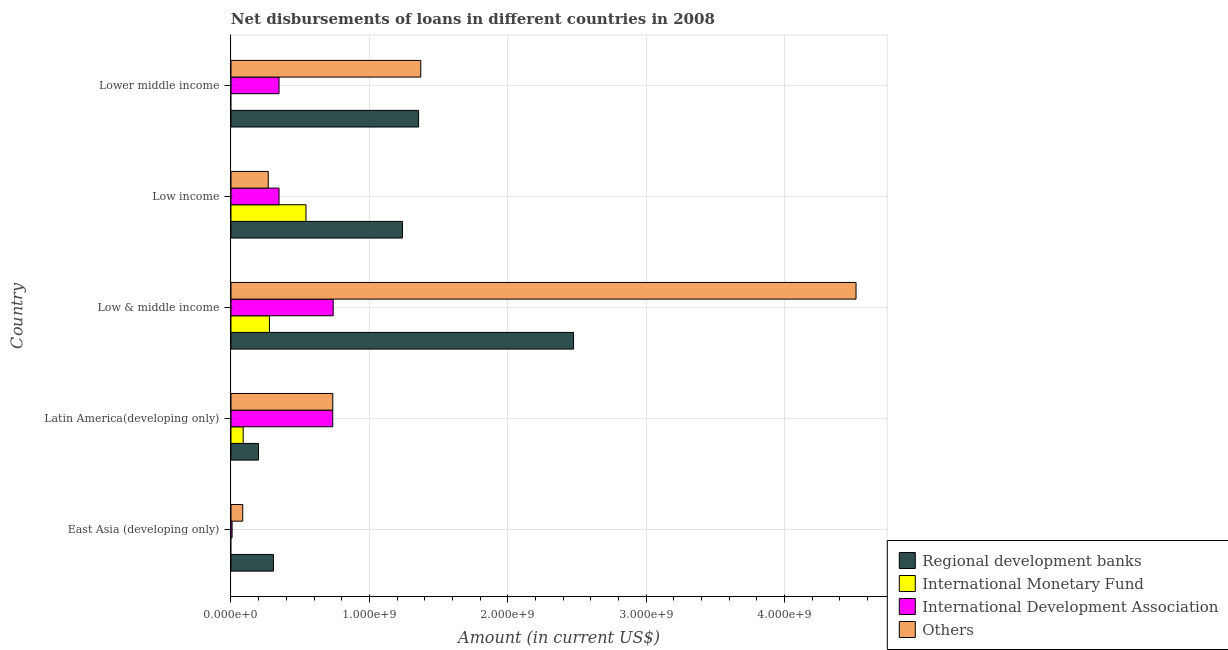Are the number of bars on each tick of the Y-axis equal?
Your answer should be compact. No. What is the label of the 1st group of bars from the top?
Keep it short and to the point. Lower middle income. In how many cases, is the number of bars for a given country not equal to the number of legend labels?
Ensure brevity in your answer.  2. What is the amount of loan disimbursed by regional development banks in East Asia (developing only)?
Give a very brief answer. 3.07e+08. Across all countries, what is the maximum amount of loan disimbursed by international monetary fund?
Your response must be concise. 5.42e+08. Across all countries, what is the minimum amount of loan disimbursed by other organisations?
Ensure brevity in your answer.  8.50e+07. In which country was the amount of loan disimbursed by regional development banks maximum?
Make the answer very short. Low & middle income. What is the total amount of loan disimbursed by regional development banks in the graph?
Your answer should be compact. 5.58e+09. What is the difference between the amount of loan disimbursed by international development association in Latin America(developing only) and that in Low & middle income?
Give a very brief answer. -3.47e+06. What is the difference between the amount of loan disimbursed by international monetary fund in Low & middle income and the amount of loan disimbursed by other organisations in East Asia (developing only)?
Make the answer very short. 1.93e+08. What is the average amount of loan disimbursed by international monetary fund per country?
Your answer should be very brief. 1.82e+08. What is the difference between the amount of loan disimbursed by international development association and amount of loan disimbursed by other organisations in East Asia (developing only)?
Give a very brief answer. -7.71e+07. What is the ratio of the amount of loan disimbursed by regional development banks in Low & middle income to that in Low income?
Your answer should be compact. 2. Is the amount of loan disimbursed by international monetary fund in Latin America(developing only) less than that in Low income?
Offer a terse response. Yes. Is the difference between the amount of loan disimbursed by regional development banks in East Asia (developing only) and Low income greater than the difference between the amount of loan disimbursed by other organisations in East Asia (developing only) and Low income?
Your answer should be very brief. No. What is the difference between the highest and the second highest amount of loan disimbursed by regional development banks?
Keep it short and to the point. 1.12e+09. What is the difference between the highest and the lowest amount of loan disimbursed by international monetary fund?
Your response must be concise. 5.42e+08. In how many countries, is the amount of loan disimbursed by regional development banks greater than the average amount of loan disimbursed by regional development banks taken over all countries?
Ensure brevity in your answer.  3. Is it the case that in every country, the sum of the amount of loan disimbursed by regional development banks and amount of loan disimbursed by international development association is greater than the sum of amount of loan disimbursed by other organisations and amount of loan disimbursed by international monetary fund?
Your response must be concise. No. Is it the case that in every country, the sum of the amount of loan disimbursed by regional development banks and amount of loan disimbursed by international monetary fund is greater than the amount of loan disimbursed by international development association?
Your answer should be very brief. No. How many bars are there?
Keep it short and to the point. 18. Are all the bars in the graph horizontal?
Make the answer very short. Yes. How many countries are there in the graph?
Make the answer very short. 5. What is the difference between two consecutive major ticks on the X-axis?
Offer a terse response. 1.00e+09. Does the graph contain grids?
Your answer should be very brief. Yes. How many legend labels are there?
Your answer should be very brief. 4. How are the legend labels stacked?
Make the answer very short. Vertical. What is the title of the graph?
Offer a terse response. Net disbursements of loans in different countries in 2008. Does "Italy" appear as one of the legend labels in the graph?
Your answer should be compact. No. What is the label or title of the X-axis?
Offer a very short reply. Amount (in current US$). What is the Amount (in current US$) in Regional development banks in East Asia (developing only)?
Your response must be concise. 3.07e+08. What is the Amount (in current US$) of International Monetary Fund in East Asia (developing only)?
Your answer should be very brief. 0. What is the Amount (in current US$) in International Development Association in East Asia (developing only)?
Offer a terse response. 7.98e+06. What is the Amount (in current US$) of Others in East Asia (developing only)?
Offer a terse response. 8.50e+07. What is the Amount (in current US$) of Regional development banks in Latin America(developing only)?
Keep it short and to the point. 1.99e+08. What is the Amount (in current US$) of International Monetary Fund in Latin America(developing only)?
Keep it short and to the point. 8.81e+07. What is the Amount (in current US$) in International Development Association in Latin America(developing only)?
Ensure brevity in your answer.  7.35e+08. What is the Amount (in current US$) in Others in Latin America(developing only)?
Keep it short and to the point. 7.36e+08. What is the Amount (in current US$) of Regional development banks in Low & middle income?
Make the answer very short. 2.48e+09. What is the Amount (in current US$) in International Monetary Fund in Low & middle income?
Provide a short and direct response. 2.78e+08. What is the Amount (in current US$) in International Development Association in Low & middle income?
Provide a short and direct response. 7.39e+08. What is the Amount (in current US$) in Others in Low & middle income?
Offer a terse response. 4.52e+09. What is the Amount (in current US$) of Regional development banks in Low income?
Offer a terse response. 1.24e+09. What is the Amount (in current US$) of International Monetary Fund in Low income?
Your answer should be very brief. 5.42e+08. What is the Amount (in current US$) of International Development Association in Low income?
Provide a short and direct response. 3.47e+08. What is the Amount (in current US$) in Others in Low income?
Your answer should be very brief. 2.69e+08. What is the Amount (in current US$) of Regional development banks in Lower middle income?
Provide a short and direct response. 1.36e+09. What is the Amount (in current US$) in International Development Association in Lower middle income?
Your answer should be compact. 3.47e+08. What is the Amount (in current US$) of Others in Lower middle income?
Provide a succinct answer. 1.37e+09. Across all countries, what is the maximum Amount (in current US$) in Regional development banks?
Provide a succinct answer. 2.48e+09. Across all countries, what is the maximum Amount (in current US$) of International Monetary Fund?
Offer a terse response. 5.42e+08. Across all countries, what is the maximum Amount (in current US$) in International Development Association?
Offer a very short reply. 7.39e+08. Across all countries, what is the maximum Amount (in current US$) in Others?
Your answer should be compact. 4.52e+09. Across all countries, what is the minimum Amount (in current US$) in Regional development banks?
Ensure brevity in your answer.  1.99e+08. Across all countries, what is the minimum Amount (in current US$) of International Development Association?
Provide a succinct answer. 7.98e+06. Across all countries, what is the minimum Amount (in current US$) of Others?
Make the answer very short. 8.50e+07. What is the total Amount (in current US$) of Regional development banks in the graph?
Your answer should be very brief. 5.58e+09. What is the total Amount (in current US$) of International Monetary Fund in the graph?
Offer a terse response. 9.08e+08. What is the total Amount (in current US$) in International Development Association in the graph?
Give a very brief answer. 2.18e+09. What is the total Amount (in current US$) of Others in the graph?
Your response must be concise. 6.98e+09. What is the difference between the Amount (in current US$) in Regional development banks in East Asia (developing only) and that in Latin America(developing only)?
Keep it short and to the point. 1.08e+08. What is the difference between the Amount (in current US$) of International Development Association in East Asia (developing only) and that in Latin America(developing only)?
Keep it short and to the point. -7.27e+08. What is the difference between the Amount (in current US$) of Others in East Asia (developing only) and that in Latin America(developing only)?
Offer a terse response. -6.51e+08. What is the difference between the Amount (in current US$) in Regional development banks in East Asia (developing only) and that in Low & middle income?
Offer a very short reply. -2.17e+09. What is the difference between the Amount (in current US$) in International Development Association in East Asia (developing only) and that in Low & middle income?
Give a very brief answer. -7.31e+08. What is the difference between the Amount (in current US$) in Others in East Asia (developing only) and that in Low & middle income?
Your answer should be compact. -4.43e+09. What is the difference between the Amount (in current US$) in Regional development banks in East Asia (developing only) and that in Low income?
Offer a very short reply. -9.32e+08. What is the difference between the Amount (in current US$) of International Development Association in East Asia (developing only) and that in Low income?
Make the answer very short. -3.39e+08. What is the difference between the Amount (in current US$) of Others in East Asia (developing only) and that in Low income?
Ensure brevity in your answer.  -1.84e+08. What is the difference between the Amount (in current US$) in Regional development banks in East Asia (developing only) and that in Lower middle income?
Make the answer very short. -1.05e+09. What is the difference between the Amount (in current US$) of International Development Association in East Asia (developing only) and that in Lower middle income?
Offer a very short reply. -3.39e+08. What is the difference between the Amount (in current US$) in Others in East Asia (developing only) and that in Lower middle income?
Your answer should be compact. -1.29e+09. What is the difference between the Amount (in current US$) in Regional development banks in Latin America(developing only) and that in Low & middle income?
Offer a very short reply. -2.28e+09. What is the difference between the Amount (in current US$) in International Monetary Fund in Latin America(developing only) and that in Low & middle income?
Your answer should be very brief. -1.90e+08. What is the difference between the Amount (in current US$) of International Development Association in Latin America(developing only) and that in Low & middle income?
Your answer should be compact. -3.47e+06. What is the difference between the Amount (in current US$) in Others in Latin America(developing only) and that in Low & middle income?
Your answer should be compact. -3.78e+09. What is the difference between the Amount (in current US$) of Regional development banks in Latin America(developing only) and that in Low income?
Provide a short and direct response. -1.04e+09. What is the difference between the Amount (in current US$) in International Monetary Fund in Latin America(developing only) and that in Low income?
Provide a short and direct response. -4.54e+08. What is the difference between the Amount (in current US$) in International Development Association in Latin America(developing only) and that in Low income?
Offer a very short reply. 3.88e+08. What is the difference between the Amount (in current US$) of Others in Latin America(developing only) and that in Low income?
Keep it short and to the point. 4.66e+08. What is the difference between the Amount (in current US$) of Regional development banks in Latin America(developing only) and that in Lower middle income?
Make the answer very short. -1.16e+09. What is the difference between the Amount (in current US$) in International Development Association in Latin America(developing only) and that in Lower middle income?
Make the answer very short. 3.88e+08. What is the difference between the Amount (in current US$) of Others in Latin America(developing only) and that in Lower middle income?
Offer a terse response. -6.36e+08. What is the difference between the Amount (in current US$) of Regional development banks in Low & middle income and that in Low income?
Make the answer very short. 1.24e+09. What is the difference between the Amount (in current US$) in International Monetary Fund in Low & middle income and that in Low income?
Keep it short and to the point. -2.64e+08. What is the difference between the Amount (in current US$) of International Development Association in Low & middle income and that in Low income?
Give a very brief answer. 3.91e+08. What is the difference between the Amount (in current US$) of Others in Low & middle income and that in Low income?
Give a very brief answer. 4.25e+09. What is the difference between the Amount (in current US$) in Regional development banks in Low & middle income and that in Lower middle income?
Provide a short and direct response. 1.12e+09. What is the difference between the Amount (in current US$) in International Development Association in Low & middle income and that in Lower middle income?
Offer a terse response. 3.91e+08. What is the difference between the Amount (in current US$) in Others in Low & middle income and that in Lower middle income?
Your response must be concise. 3.14e+09. What is the difference between the Amount (in current US$) in Regional development banks in Low income and that in Lower middle income?
Your response must be concise. -1.16e+08. What is the difference between the Amount (in current US$) of Others in Low income and that in Lower middle income?
Provide a succinct answer. -1.10e+09. What is the difference between the Amount (in current US$) in Regional development banks in East Asia (developing only) and the Amount (in current US$) in International Monetary Fund in Latin America(developing only)?
Your answer should be very brief. 2.19e+08. What is the difference between the Amount (in current US$) in Regional development banks in East Asia (developing only) and the Amount (in current US$) in International Development Association in Latin America(developing only)?
Your response must be concise. -4.28e+08. What is the difference between the Amount (in current US$) in Regional development banks in East Asia (developing only) and the Amount (in current US$) in Others in Latin America(developing only)?
Provide a short and direct response. -4.29e+08. What is the difference between the Amount (in current US$) in International Development Association in East Asia (developing only) and the Amount (in current US$) in Others in Latin America(developing only)?
Give a very brief answer. -7.28e+08. What is the difference between the Amount (in current US$) of Regional development banks in East Asia (developing only) and the Amount (in current US$) of International Monetary Fund in Low & middle income?
Offer a very short reply. 2.89e+07. What is the difference between the Amount (in current US$) of Regional development banks in East Asia (developing only) and the Amount (in current US$) of International Development Association in Low & middle income?
Your answer should be very brief. -4.32e+08. What is the difference between the Amount (in current US$) in Regional development banks in East Asia (developing only) and the Amount (in current US$) in Others in Low & middle income?
Ensure brevity in your answer.  -4.21e+09. What is the difference between the Amount (in current US$) in International Development Association in East Asia (developing only) and the Amount (in current US$) in Others in Low & middle income?
Give a very brief answer. -4.51e+09. What is the difference between the Amount (in current US$) of Regional development banks in East Asia (developing only) and the Amount (in current US$) of International Monetary Fund in Low income?
Make the answer very short. -2.35e+08. What is the difference between the Amount (in current US$) of Regional development banks in East Asia (developing only) and the Amount (in current US$) of International Development Association in Low income?
Keep it short and to the point. -4.06e+07. What is the difference between the Amount (in current US$) in Regional development banks in East Asia (developing only) and the Amount (in current US$) in Others in Low income?
Your answer should be compact. 3.74e+07. What is the difference between the Amount (in current US$) of International Development Association in East Asia (developing only) and the Amount (in current US$) of Others in Low income?
Make the answer very short. -2.61e+08. What is the difference between the Amount (in current US$) in Regional development banks in East Asia (developing only) and the Amount (in current US$) in International Development Association in Lower middle income?
Offer a terse response. -4.06e+07. What is the difference between the Amount (in current US$) of Regional development banks in East Asia (developing only) and the Amount (in current US$) of Others in Lower middle income?
Offer a very short reply. -1.06e+09. What is the difference between the Amount (in current US$) of International Development Association in East Asia (developing only) and the Amount (in current US$) of Others in Lower middle income?
Your response must be concise. -1.36e+09. What is the difference between the Amount (in current US$) in Regional development banks in Latin America(developing only) and the Amount (in current US$) in International Monetary Fund in Low & middle income?
Offer a terse response. -7.86e+07. What is the difference between the Amount (in current US$) of Regional development banks in Latin America(developing only) and the Amount (in current US$) of International Development Association in Low & middle income?
Make the answer very short. -5.39e+08. What is the difference between the Amount (in current US$) of Regional development banks in Latin America(developing only) and the Amount (in current US$) of Others in Low & middle income?
Offer a terse response. -4.32e+09. What is the difference between the Amount (in current US$) in International Monetary Fund in Latin America(developing only) and the Amount (in current US$) in International Development Association in Low & middle income?
Offer a very short reply. -6.50e+08. What is the difference between the Amount (in current US$) in International Monetary Fund in Latin America(developing only) and the Amount (in current US$) in Others in Low & middle income?
Your answer should be compact. -4.43e+09. What is the difference between the Amount (in current US$) of International Development Association in Latin America(developing only) and the Amount (in current US$) of Others in Low & middle income?
Offer a very short reply. -3.78e+09. What is the difference between the Amount (in current US$) of Regional development banks in Latin America(developing only) and the Amount (in current US$) of International Monetary Fund in Low income?
Give a very brief answer. -3.43e+08. What is the difference between the Amount (in current US$) of Regional development banks in Latin America(developing only) and the Amount (in current US$) of International Development Association in Low income?
Your answer should be compact. -1.48e+08. What is the difference between the Amount (in current US$) of Regional development banks in Latin America(developing only) and the Amount (in current US$) of Others in Low income?
Keep it short and to the point. -7.01e+07. What is the difference between the Amount (in current US$) in International Monetary Fund in Latin America(developing only) and the Amount (in current US$) in International Development Association in Low income?
Provide a succinct answer. -2.59e+08. What is the difference between the Amount (in current US$) in International Monetary Fund in Latin America(developing only) and the Amount (in current US$) in Others in Low income?
Give a very brief answer. -1.81e+08. What is the difference between the Amount (in current US$) of International Development Association in Latin America(developing only) and the Amount (in current US$) of Others in Low income?
Keep it short and to the point. 4.66e+08. What is the difference between the Amount (in current US$) in Regional development banks in Latin America(developing only) and the Amount (in current US$) in International Development Association in Lower middle income?
Keep it short and to the point. -1.48e+08. What is the difference between the Amount (in current US$) in Regional development banks in Latin America(developing only) and the Amount (in current US$) in Others in Lower middle income?
Offer a very short reply. -1.17e+09. What is the difference between the Amount (in current US$) of International Monetary Fund in Latin America(developing only) and the Amount (in current US$) of International Development Association in Lower middle income?
Your response must be concise. -2.59e+08. What is the difference between the Amount (in current US$) in International Monetary Fund in Latin America(developing only) and the Amount (in current US$) in Others in Lower middle income?
Provide a succinct answer. -1.28e+09. What is the difference between the Amount (in current US$) of International Development Association in Latin America(developing only) and the Amount (in current US$) of Others in Lower middle income?
Make the answer very short. -6.36e+08. What is the difference between the Amount (in current US$) of Regional development banks in Low & middle income and the Amount (in current US$) of International Monetary Fund in Low income?
Your answer should be very brief. 1.93e+09. What is the difference between the Amount (in current US$) of Regional development banks in Low & middle income and the Amount (in current US$) of International Development Association in Low income?
Offer a terse response. 2.13e+09. What is the difference between the Amount (in current US$) of Regional development banks in Low & middle income and the Amount (in current US$) of Others in Low income?
Keep it short and to the point. 2.21e+09. What is the difference between the Amount (in current US$) of International Monetary Fund in Low & middle income and the Amount (in current US$) of International Development Association in Low income?
Your answer should be very brief. -6.95e+07. What is the difference between the Amount (in current US$) in International Monetary Fund in Low & middle income and the Amount (in current US$) in Others in Low income?
Provide a succinct answer. 8.55e+06. What is the difference between the Amount (in current US$) of International Development Association in Low & middle income and the Amount (in current US$) of Others in Low income?
Offer a terse response. 4.69e+08. What is the difference between the Amount (in current US$) in Regional development banks in Low & middle income and the Amount (in current US$) in International Development Association in Lower middle income?
Provide a short and direct response. 2.13e+09. What is the difference between the Amount (in current US$) in Regional development banks in Low & middle income and the Amount (in current US$) in Others in Lower middle income?
Make the answer very short. 1.10e+09. What is the difference between the Amount (in current US$) in International Monetary Fund in Low & middle income and the Amount (in current US$) in International Development Association in Lower middle income?
Give a very brief answer. -6.95e+07. What is the difference between the Amount (in current US$) in International Monetary Fund in Low & middle income and the Amount (in current US$) in Others in Lower middle income?
Provide a succinct answer. -1.09e+09. What is the difference between the Amount (in current US$) of International Development Association in Low & middle income and the Amount (in current US$) of Others in Lower middle income?
Your answer should be very brief. -6.33e+08. What is the difference between the Amount (in current US$) of Regional development banks in Low income and the Amount (in current US$) of International Development Association in Lower middle income?
Give a very brief answer. 8.92e+08. What is the difference between the Amount (in current US$) in Regional development banks in Low income and the Amount (in current US$) in Others in Lower middle income?
Your answer should be compact. -1.32e+08. What is the difference between the Amount (in current US$) of International Monetary Fund in Low income and the Amount (in current US$) of International Development Association in Lower middle income?
Your response must be concise. 1.95e+08. What is the difference between the Amount (in current US$) of International Monetary Fund in Low income and the Amount (in current US$) of Others in Lower middle income?
Provide a succinct answer. -8.29e+08. What is the difference between the Amount (in current US$) in International Development Association in Low income and the Amount (in current US$) in Others in Lower middle income?
Your answer should be very brief. -1.02e+09. What is the average Amount (in current US$) in Regional development banks per country?
Your answer should be very brief. 1.12e+09. What is the average Amount (in current US$) of International Monetary Fund per country?
Provide a succinct answer. 1.82e+08. What is the average Amount (in current US$) in International Development Association per country?
Your answer should be very brief. 4.35e+08. What is the average Amount (in current US$) in Others per country?
Provide a succinct answer. 1.40e+09. What is the difference between the Amount (in current US$) of Regional development banks and Amount (in current US$) of International Development Association in East Asia (developing only)?
Offer a very short reply. 2.99e+08. What is the difference between the Amount (in current US$) in Regional development banks and Amount (in current US$) in Others in East Asia (developing only)?
Make the answer very short. 2.22e+08. What is the difference between the Amount (in current US$) in International Development Association and Amount (in current US$) in Others in East Asia (developing only)?
Provide a short and direct response. -7.71e+07. What is the difference between the Amount (in current US$) of Regional development banks and Amount (in current US$) of International Monetary Fund in Latin America(developing only)?
Offer a very short reply. 1.11e+08. What is the difference between the Amount (in current US$) of Regional development banks and Amount (in current US$) of International Development Association in Latin America(developing only)?
Ensure brevity in your answer.  -5.36e+08. What is the difference between the Amount (in current US$) in Regional development banks and Amount (in current US$) in Others in Latin America(developing only)?
Your response must be concise. -5.36e+08. What is the difference between the Amount (in current US$) in International Monetary Fund and Amount (in current US$) in International Development Association in Latin America(developing only)?
Ensure brevity in your answer.  -6.47e+08. What is the difference between the Amount (in current US$) in International Monetary Fund and Amount (in current US$) in Others in Latin America(developing only)?
Your answer should be very brief. -6.48e+08. What is the difference between the Amount (in current US$) in International Development Association and Amount (in current US$) in Others in Latin America(developing only)?
Your answer should be compact. -5.26e+05. What is the difference between the Amount (in current US$) in Regional development banks and Amount (in current US$) in International Monetary Fund in Low & middle income?
Make the answer very short. 2.20e+09. What is the difference between the Amount (in current US$) in Regional development banks and Amount (in current US$) in International Development Association in Low & middle income?
Make the answer very short. 1.74e+09. What is the difference between the Amount (in current US$) of Regional development banks and Amount (in current US$) of Others in Low & middle income?
Your answer should be compact. -2.04e+09. What is the difference between the Amount (in current US$) in International Monetary Fund and Amount (in current US$) in International Development Association in Low & middle income?
Give a very brief answer. -4.61e+08. What is the difference between the Amount (in current US$) in International Monetary Fund and Amount (in current US$) in Others in Low & middle income?
Your answer should be compact. -4.24e+09. What is the difference between the Amount (in current US$) in International Development Association and Amount (in current US$) in Others in Low & middle income?
Your answer should be compact. -3.78e+09. What is the difference between the Amount (in current US$) in Regional development banks and Amount (in current US$) in International Monetary Fund in Low income?
Provide a succinct answer. 6.97e+08. What is the difference between the Amount (in current US$) in Regional development banks and Amount (in current US$) in International Development Association in Low income?
Offer a terse response. 8.92e+08. What is the difference between the Amount (in current US$) of Regional development banks and Amount (in current US$) of Others in Low income?
Provide a succinct answer. 9.70e+08. What is the difference between the Amount (in current US$) of International Monetary Fund and Amount (in current US$) of International Development Association in Low income?
Ensure brevity in your answer.  1.95e+08. What is the difference between the Amount (in current US$) of International Monetary Fund and Amount (in current US$) of Others in Low income?
Offer a very short reply. 2.73e+08. What is the difference between the Amount (in current US$) of International Development Association and Amount (in current US$) of Others in Low income?
Your response must be concise. 7.81e+07. What is the difference between the Amount (in current US$) in Regional development banks and Amount (in current US$) in International Development Association in Lower middle income?
Offer a very short reply. 1.01e+09. What is the difference between the Amount (in current US$) in Regional development banks and Amount (in current US$) in Others in Lower middle income?
Give a very brief answer. -1.59e+07. What is the difference between the Amount (in current US$) of International Development Association and Amount (in current US$) of Others in Lower middle income?
Offer a very short reply. -1.02e+09. What is the ratio of the Amount (in current US$) in Regional development banks in East Asia (developing only) to that in Latin America(developing only)?
Your response must be concise. 1.54. What is the ratio of the Amount (in current US$) in International Development Association in East Asia (developing only) to that in Latin America(developing only)?
Keep it short and to the point. 0.01. What is the ratio of the Amount (in current US$) of Others in East Asia (developing only) to that in Latin America(developing only)?
Provide a short and direct response. 0.12. What is the ratio of the Amount (in current US$) of Regional development banks in East Asia (developing only) to that in Low & middle income?
Your answer should be very brief. 0.12. What is the ratio of the Amount (in current US$) in International Development Association in East Asia (developing only) to that in Low & middle income?
Your answer should be very brief. 0.01. What is the ratio of the Amount (in current US$) in Others in East Asia (developing only) to that in Low & middle income?
Make the answer very short. 0.02. What is the ratio of the Amount (in current US$) in Regional development banks in East Asia (developing only) to that in Low income?
Give a very brief answer. 0.25. What is the ratio of the Amount (in current US$) in International Development Association in East Asia (developing only) to that in Low income?
Your answer should be very brief. 0.02. What is the ratio of the Amount (in current US$) in Others in East Asia (developing only) to that in Low income?
Your answer should be very brief. 0.32. What is the ratio of the Amount (in current US$) in Regional development banks in East Asia (developing only) to that in Lower middle income?
Make the answer very short. 0.23. What is the ratio of the Amount (in current US$) in International Development Association in East Asia (developing only) to that in Lower middle income?
Your answer should be compact. 0.02. What is the ratio of the Amount (in current US$) in Others in East Asia (developing only) to that in Lower middle income?
Provide a short and direct response. 0.06. What is the ratio of the Amount (in current US$) in Regional development banks in Latin America(developing only) to that in Low & middle income?
Make the answer very short. 0.08. What is the ratio of the Amount (in current US$) of International Monetary Fund in Latin America(developing only) to that in Low & middle income?
Your answer should be compact. 0.32. What is the ratio of the Amount (in current US$) in Others in Latin America(developing only) to that in Low & middle income?
Ensure brevity in your answer.  0.16. What is the ratio of the Amount (in current US$) in Regional development banks in Latin America(developing only) to that in Low income?
Make the answer very short. 0.16. What is the ratio of the Amount (in current US$) in International Monetary Fund in Latin America(developing only) to that in Low income?
Ensure brevity in your answer.  0.16. What is the ratio of the Amount (in current US$) in International Development Association in Latin America(developing only) to that in Low income?
Your answer should be very brief. 2.12. What is the ratio of the Amount (in current US$) of Others in Latin America(developing only) to that in Low income?
Provide a short and direct response. 2.73. What is the ratio of the Amount (in current US$) of Regional development banks in Latin America(developing only) to that in Lower middle income?
Your response must be concise. 0.15. What is the ratio of the Amount (in current US$) of International Development Association in Latin America(developing only) to that in Lower middle income?
Give a very brief answer. 2.12. What is the ratio of the Amount (in current US$) of Others in Latin America(developing only) to that in Lower middle income?
Your answer should be compact. 0.54. What is the ratio of the Amount (in current US$) in Regional development banks in Low & middle income to that in Low income?
Offer a terse response. 2. What is the ratio of the Amount (in current US$) in International Monetary Fund in Low & middle income to that in Low income?
Your answer should be compact. 0.51. What is the ratio of the Amount (in current US$) of International Development Association in Low & middle income to that in Low income?
Provide a succinct answer. 2.13. What is the ratio of the Amount (in current US$) of Others in Low & middle income to that in Low income?
Make the answer very short. 16.77. What is the ratio of the Amount (in current US$) of Regional development banks in Low & middle income to that in Lower middle income?
Your answer should be very brief. 1.83. What is the ratio of the Amount (in current US$) of International Development Association in Low & middle income to that in Lower middle income?
Give a very brief answer. 2.13. What is the ratio of the Amount (in current US$) of Others in Low & middle income to that in Lower middle income?
Your response must be concise. 3.29. What is the ratio of the Amount (in current US$) in Regional development banks in Low income to that in Lower middle income?
Provide a short and direct response. 0.91. What is the ratio of the Amount (in current US$) in Others in Low income to that in Lower middle income?
Provide a short and direct response. 0.2. What is the difference between the highest and the second highest Amount (in current US$) of Regional development banks?
Offer a terse response. 1.12e+09. What is the difference between the highest and the second highest Amount (in current US$) of International Monetary Fund?
Offer a very short reply. 2.64e+08. What is the difference between the highest and the second highest Amount (in current US$) in International Development Association?
Your answer should be compact. 3.47e+06. What is the difference between the highest and the second highest Amount (in current US$) of Others?
Make the answer very short. 3.14e+09. What is the difference between the highest and the lowest Amount (in current US$) of Regional development banks?
Give a very brief answer. 2.28e+09. What is the difference between the highest and the lowest Amount (in current US$) in International Monetary Fund?
Offer a very short reply. 5.42e+08. What is the difference between the highest and the lowest Amount (in current US$) in International Development Association?
Keep it short and to the point. 7.31e+08. What is the difference between the highest and the lowest Amount (in current US$) of Others?
Ensure brevity in your answer.  4.43e+09. 